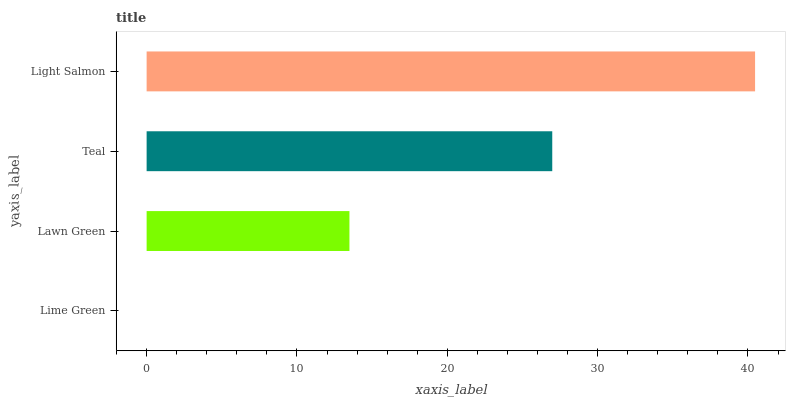Is Lime Green the minimum?
Answer yes or no. Yes. Is Light Salmon the maximum?
Answer yes or no. Yes. Is Lawn Green the minimum?
Answer yes or no. No. Is Lawn Green the maximum?
Answer yes or no. No. Is Lawn Green greater than Lime Green?
Answer yes or no. Yes. Is Lime Green less than Lawn Green?
Answer yes or no. Yes. Is Lime Green greater than Lawn Green?
Answer yes or no. No. Is Lawn Green less than Lime Green?
Answer yes or no. No. Is Teal the high median?
Answer yes or no. Yes. Is Lawn Green the low median?
Answer yes or no. Yes. Is Light Salmon the high median?
Answer yes or no. No. Is Light Salmon the low median?
Answer yes or no. No. 